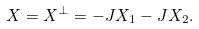<formula> <loc_0><loc_0><loc_500><loc_500>X = X ^ { \perp } = - J X _ { 1 } - J X _ { 2 } .</formula> 